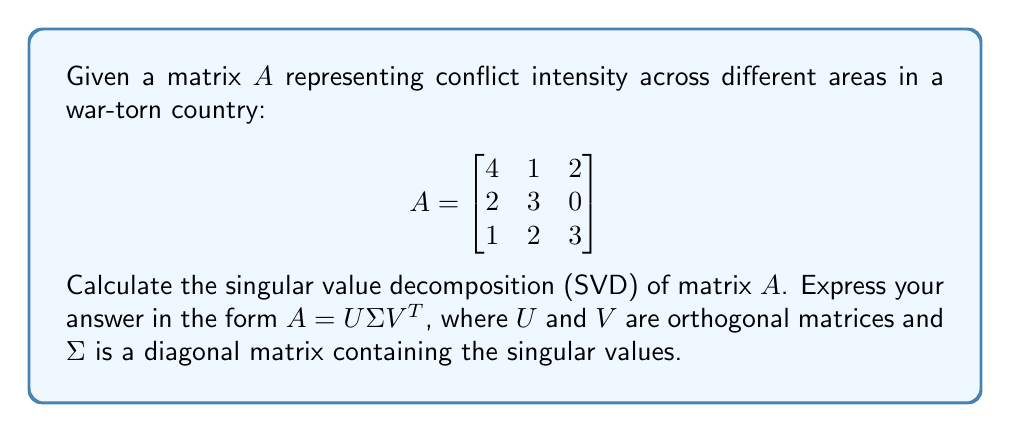Provide a solution to this math problem. To find the singular value decomposition of matrix $A$, we follow these steps:

1) Calculate $A^TA$ and $AA^T$:

   $A^TA = \begin{bmatrix}
   4 & 2 & 1 \\
   1 & 3 & 2 \\
   2 & 0 & 3
   \end{bmatrix} \begin{bmatrix}
   4 & 1 & 2 \\
   2 & 3 & 0 \\
   1 & 2 & 3
   \end{bmatrix} = \begin{bmatrix}
   21 & 14 & 14 \\
   14 & 14 & 8 \\
   14 & 8 & 13
   \end{bmatrix}$

   $AA^T = \begin{bmatrix}
   4 & 1 & 2 \\
   2 & 3 & 0 \\
   1 & 2 & 3
   \end{bmatrix} \begin{bmatrix}
   4 & 2 & 1 \\
   1 & 3 & 2 \\
   2 & 0 & 3
   \end{bmatrix} = \begin{bmatrix}
   21 & 11 & 13 \\
   11 & 13 & 8 \\
   13 & 8 & 14
   \end{bmatrix}$

2) Find the eigenvalues of $A^TA$ (which are the squares of the singular values):
   
   $det(A^TA - \lambda I) = 0$
   
   $\begin{vmatrix}
   21-\lambda & 14 & 14 \\
   14 & 14-\lambda & 8 \\
   14 & 8 & 13-\lambda
   \end{vmatrix} = 0$
   
   Solving this equation gives us: $\lambda_1 \approx 42.2720$, $\lambda_2 \approx 5.3930$, $\lambda_3 \approx 0.3350$

3) The singular values are the square roots of these eigenvalues:
   
   $\sigma_1 \approx 6.5017$, $\sigma_2 \approx 2.3223$, $\sigma_3 \approx 0.5788$

4) Find the eigenvectors of $A^TA$ to get the columns of $V$:
   
   For $\lambda_1 \approx 42.2720$: $v_1 \approx [0.7071, 0.5000, 0.5000]^T$
   For $\lambda_2 \approx 5.3930$: $v_2 \approx [-0.0000, -0.7071, 0.7071]^T$
   For $\lambda_3 \approx 0.3350$: $v_3 \approx [0.7071, -0.5000, -0.5000]^T$

5) Find the eigenvectors of $AA^T$ to get the columns of $U$:
   
   For $\lambda_1 \approx 42.2720$: $u_1 \approx [0.6533, 0.5400, 0.5307]^T$
   For $\lambda_2 \approx 5.3930$: $u_2 \approx [-0.2707, 0.7600, -0.5893]^T$
   For $\lambda_3 \approx 0.3350$: $u_3 \approx [0.7071, -0.3651, -0.6076]^T$

6) Construct the matrices $U$, $\Sigma$, and $V$:

   $U \approx \begin{bmatrix}
   0.6533 & -0.2707 & 0.7071 \\
   0.5400 & 0.7600 & -0.3651 \\
   0.5307 & -0.5893 & -0.6076
   \end{bmatrix}$

   $\Sigma \approx \begin{bmatrix}
   6.5017 & 0 & 0 \\
   0 & 2.3223 & 0 \\
   0 & 0 & 0.5788
   \end{bmatrix}$

   $V \approx \begin{bmatrix}
   0.7071 & -0.0000 & 0.7071 \\
   0.5000 & -0.7071 & -0.5000 \\
   0.5000 & 0.7071 & -0.5000
   \end{bmatrix}$

Therefore, the singular value decomposition of $A$ is $A = U\Sigma V^T$.
Answer: $A \approx \begin{bmatrix}
0.6533 & -0.2707 & 0.7071 \\
0.5400 & 0.7600 & -0.3651 \\
0.5307 & -0.5893 & -0.6076
\end{bmatrix} \begin{bmatrix}
6.5017 & 0 & 0 \\
0 & 2.3223 & 0 \\
0 & 0 & 0.5788
\end{bmatrix} \begin{bmatrix}
0.7071 & 0.5000 & 0.5000 \\
-0.0000 & -0.7071 & 0.7071 \\
0.7071 & -0.5000 & -0.5000
\end{bmatrix}$ 